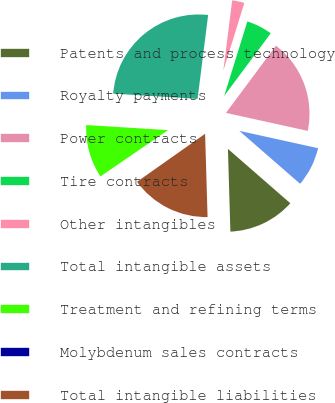<chart> <loc_0><loc_0><loc_500><loc_500><pie_chart><fcel>Patents and process technology<fcel>Royalty payments<fcel>Power contracts<fcel>Tire contracts<fcel>Other intangibles<fcel>Total intangible assets<fcel>Treatment and refining terms<fcel>Molybdenum sales contracts<fcel>Total intangible liabilities<nl><fcel>13.12%<fcel>7.96%<fcel>18.28%<fcel>5.38%<fcel>2.8%<fcel>26.01%<fcel>10.54%<fcel>0.22%<fcel>15.7%<nl></chart> 